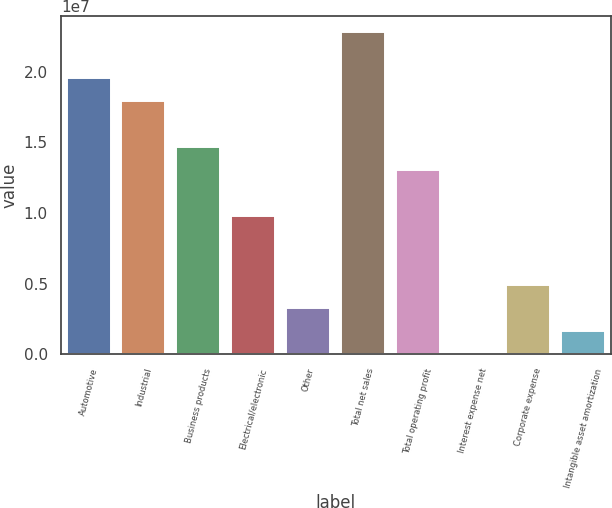Convert chart. <chart><loc_0><loc_0><loc_500><loc_500><bar_chart><fcel>Automotive<fcel>Industrial<fcel>Business products<fcel>Electrical/electronic<fcel>Other<fcel>Total net sales<fcel>Total operating profit<fcel>Interest expense net<fcel>Corporate expense<fcel>Intangible asset amortization<nl><fcel>1.95628e+07<fcel>1.79358e+07<fcel>1.46818e+07<fcel>9.80075e+06<fcel>3.2927e+06<fcel>2.28169e+07<fcel>1.30548e+07<fcel>38677<fcel>4.91971e+06<fcel>1.66569e+06<nl></chart> 